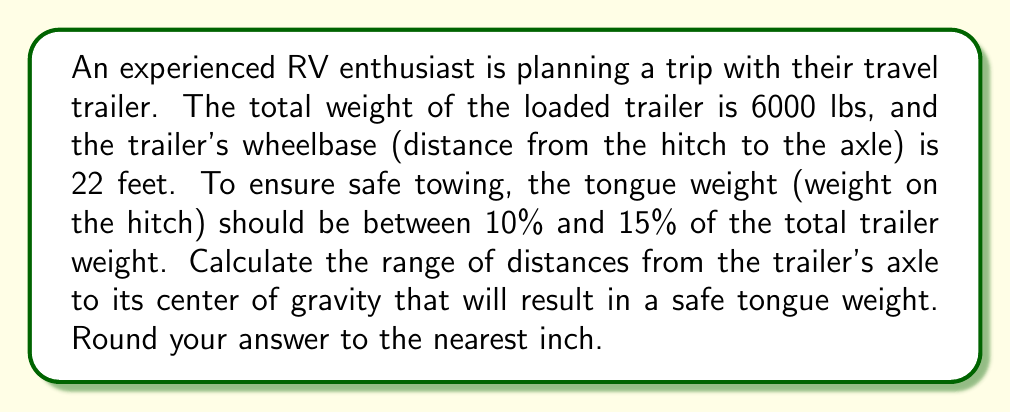Solve this math problem. Let's approach this step-by-step:

1) First, let's define our variables:
   $W$ = Total weight of the trailer = 6000 lbs
   $L$ = Wheelbase = 22 feet
   $x$ = Distance from axle to center of gravity (CG)
   $T$ = Tongue weight

2) We know that the tongue weight should be between 10% and 15% of the total weight:
   $0.10W \leq T \leq 0.15W$
   $600 \leq T \leq 900$

3) Using the principle of moments, we can set up an equation:
   $T \cdot L = W \cdot x$

4) Substituting the known values:
   $T \cdot 22 = 6000 \cdot x$

5) We want to solve for $x$, so:
   $x = \frac{22T}{6000} = \frac{11T}{3000}$

6) Now, we can substitute our tongue weight range:
   For minimum $x$: $x_{min} = \frac{11 \cdot 600}{3000} = 2.2$ feet
   For maximum $x$: $x_{max} = \frac{11 \cdot 900}{3000} = 3.3$ feet

7) Converting to inches and rounding to the nearest inch:
   $x_{min} = 2.2 \cdot 12 \approx 26$ inches
   $x_{max} = 3.3 \cdot 12 \approx 40$ inches

Therefore, the center of gravity should be between 26 and 40 inches from the axle for safe towing.
Answer: The safe range for the distance from the trailer's axle to its center of gravity is 26 to 40 inches. 